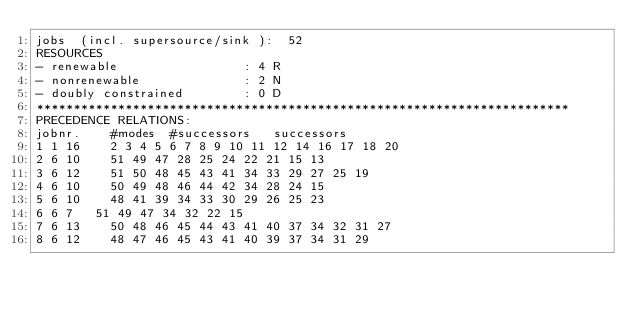<code> <loc_0><loc_0><loc_500><loc_500><_ObjectiveC_>jobs  (incl. supersource/sink ):	52
RESOURCES
- renewable                 : 4 R
- nonrenewable              : 2 N
- doubly constrained        : 0 D
************************************************************************
PRECEDENCE RELATIONS:
jobnr.    #modes  #successors   successors
1	1	16		2 3 4 5 6 7 8 9 10 11 12 14 16 17 18 20 
2	6	10		51 49 47 28 25 24 22 21 15 13 
3	6	12		51 50 48 45 43 41 34 33 29 27 25 19 
4	6	10		50 49 48 46 44 42 34 28 24 15 
5	6	10		48 41 39 34 33 30 29 26 25 23 
6	6	7		51 49 47 34 32 22 15 
7	6	13		50 48 46 45 44 43 41 40 37 34 32 31 27 
8	6	12		48 47 46 45 43 41 40 39 37 34 31 29 </code> 